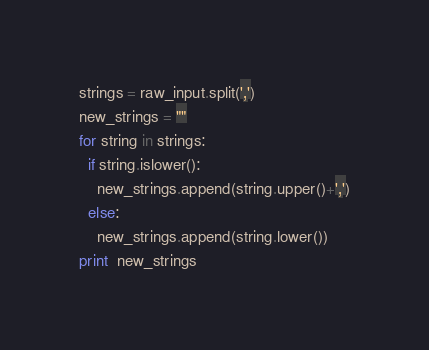Convert code to text. <code><loc_0><loc_0><loc_500><loc_500><_Python_>strings = raw_input.split(',')
new_strings = ""
for string in strings:
  if string.islower():
    new_strings.append(string.upper()+',')
  else:
    new_strings.append(string.lower())
print  new_strings</code> 